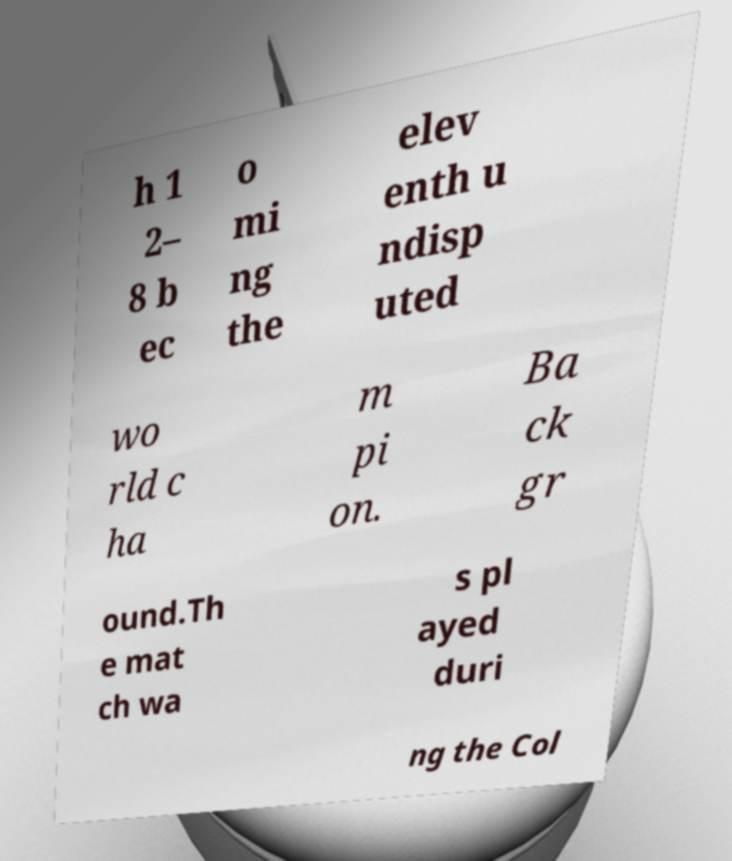Can you accurately transcribe the text from the provided image for me? h 1 2– 8 b ec o mi ng the elev enth u ndisp uted wo rld c ha m pi on. Ba ck gr ound.Th e mat ch wa s pl ayed duri ng the Col 